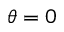<formula> <loc_0><loc_0><loc_500><loc_500>\theta = 0</formula> 